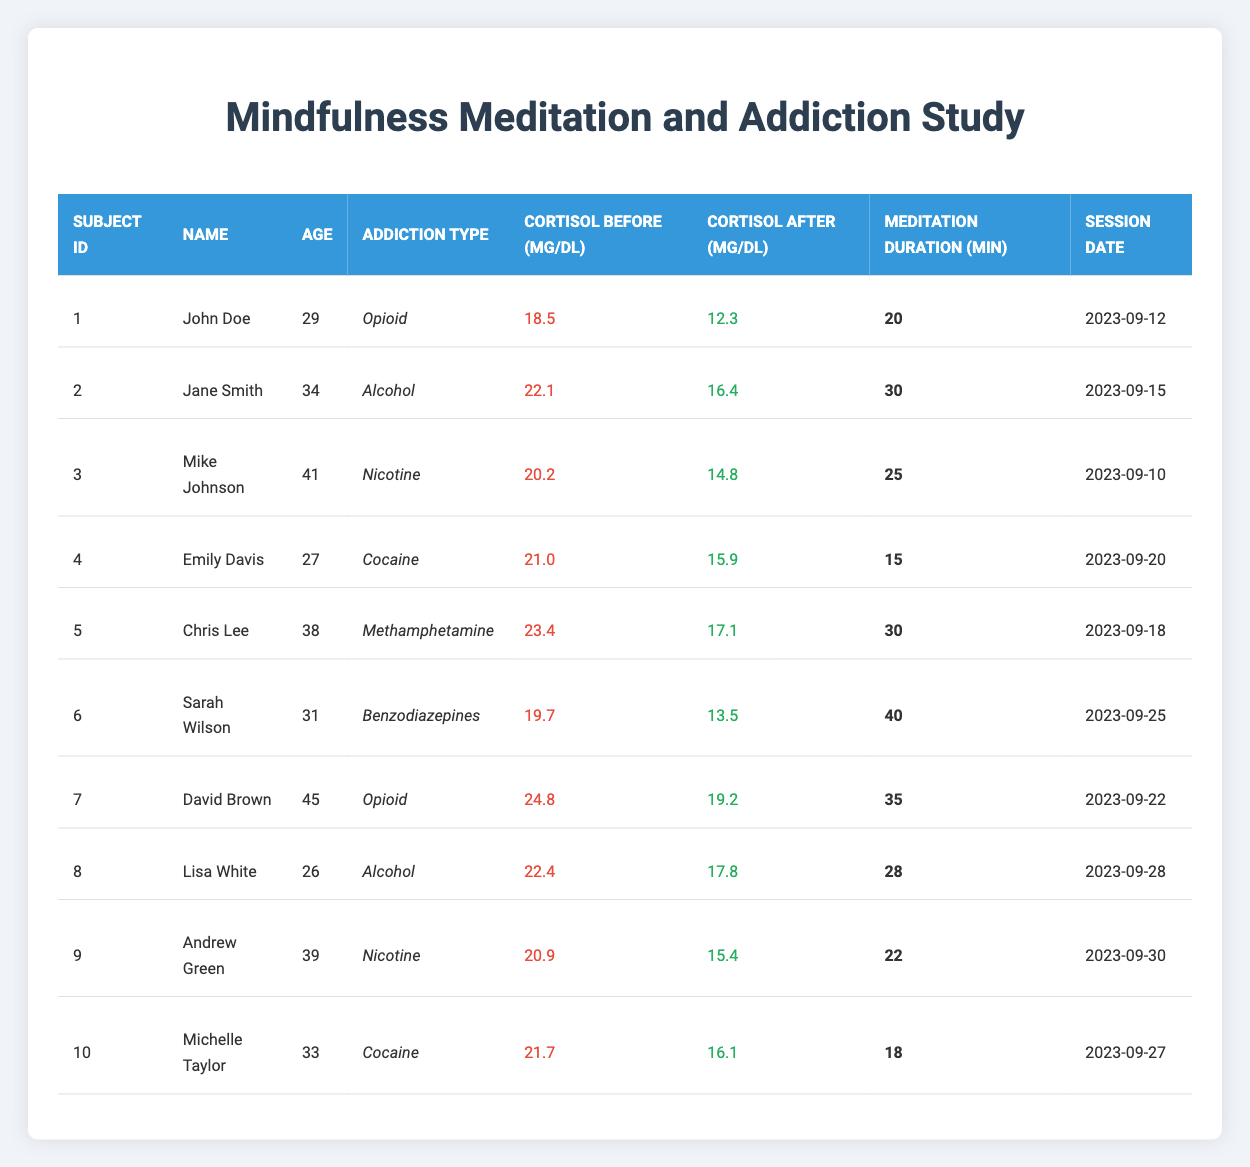What is the median cortisol level before the meditation sessions? To find the median cortisol level before meditation, first, I will sort the cortisol_before values: 18.5, 19.7, 20.2, 20.9, 21.0, 21.7, 22.1, 22.4, 23.4, 24.8. With 10 data points, the median will be the average of the 5th and 6th values: (21.0 + 21.7) / 2 = 21.35
Answer: 21.35 Which individual had the highest cortisol level before the meditation session? By reviewing the cortisol_before values: 18.5, 22.1, 20.2, 21.0, 23.4, 19.7, 24.8, 22.4, 20.9, and 21.7, I can see that 24.8 is the highest, found in David Brown's data.
Answer: David Brown Was the cortisol level after meditation lower for all individuals compared to before? I will check each cortisol_after value against its corresponding cortisol_before value. Comparing the values shows that John Doe, Jane Smith, Mike Johnson, Emily Davis, Chris Lee, and Sarah Wilson had lower levels after. However, David Brown and Lisa White had higher levels after meditation. Therefore, the statement is false.
Answer: No How much did cortisol levels decrease on average after meditation sessions? I will calculate the change for each individual by subtracting the cortisol_after from cortisol_before, then find the average of these changes: (6.2 + 5.7 + 5.4 + 5.1 + 6.3 + 6.2 + 5.6 + 4.6 + 5.5 + 5.6) / 10 = 5.61.
Answer: 5.61 What percentage of participants reported a decrease in cortisol levels after meditation? Out of 10 participants, 8 had lower cortisol levels after meditation. To find the percentage, I calculate (8/10) * 100 = 80%.
Answer: 80% Which type of addiction had the highest average cortisol level before meditation? I will group the individuals by addiction type and calculate the average cortisol_before for each group. Opioid: (18.5 + 24.8) / 2 = 21.65, Alcohol: (22.1 + 22.4) / 2 = 22.25, Nicotine: (20.2 + 20.9) / 2 = 20.55, Cocaine: (21.0 + 21.7) / 2 = 21.35, Methamphetamine: 23.4. The highest average is for Alcohol.
Answer: Alcohol What was the longest meditation duration and who practiced it? By reviewing the meditation_duration column, the highest value is 40 minutes, practiced by Sarah Wilson.
Answer: Sarah Wilson Did any individuals with cocaine addiction have an increase in cortisol after meditation? Checking the cortisol_after values for both Cocaine addiction individuals: Emily Davis had 15.9 (decrease), and Michelle Taylor had 16.1 (decrease). Both had lower levels after meditation.
Answer: No 